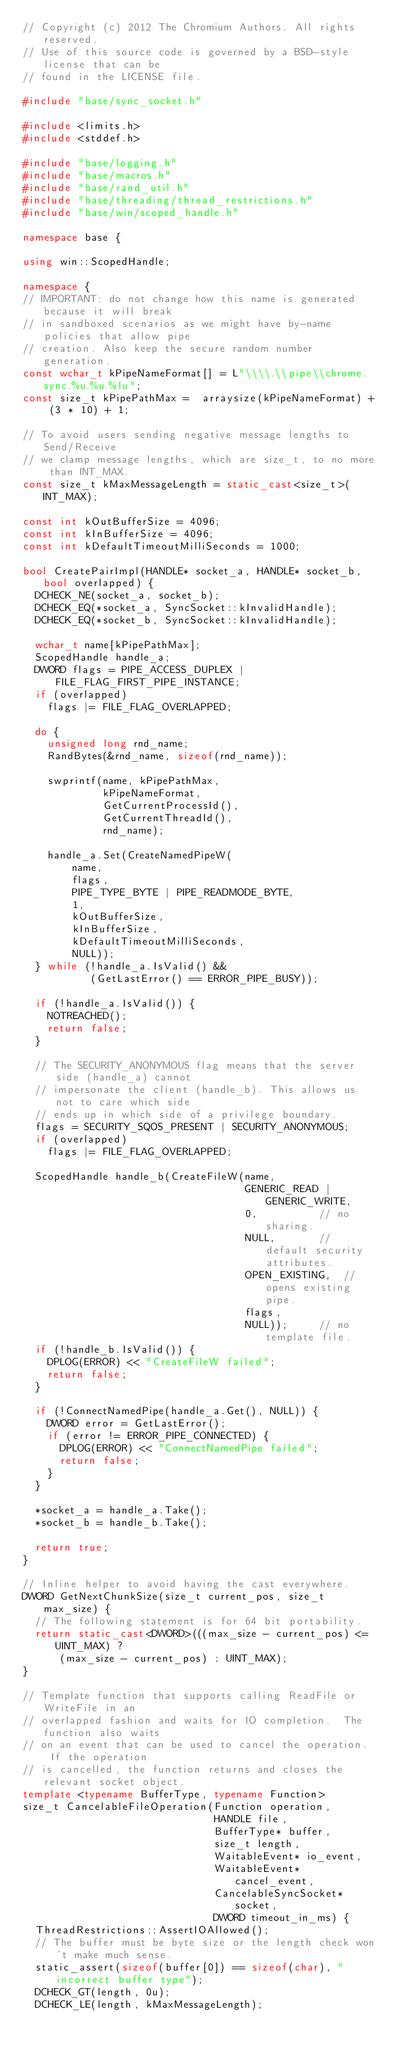<code> <loc_0><loc_0><loc_500><loc_500><_C++_>// Copyright (c) 2012 The Chromium Authors. All rights reserved.
// Use of this source code is governed by a BSD-style license that can be
// found in the LICENSE file.

#include "base/sync_socket.h"

#include <limits.h>
#include <stddef.h>

#include "base/logging.h"
#include "base/macros.h"
#include "base/rand_util.h"
#include "base/threading/thread_restrictions.h"
#include "base/win/scoped_handle.h"

namespace base {

using win::ScopedHandle;

namespace {
// IMPORTANT: do not change how this name is generated because it will break
// in sandboxed scenarios as we might have by-name policies that allow pipe
// creation. Also keep the secure random number generation.
const wchar_t kPipeNameFormat[] = L"\\\\.\\pipe\\chrome.sync.%u.%u.%lu";
const size_t kPipePathMax =  arraysize(kPipeNameFormat) + (3 * 10) + 1;

// To avoid users sending negative message lengths to Send/Receive
// we clamp message lengths, which are size_t, to no more than INT_MAX.
const size_t kMaxMessageLength = static_cast<size_t>(INT_MAX);

const int kOutBufferSize = 4096;
const int kInBufferSize = 4096;
const int kDefaultTimeoutMilliSeconds = 1000;

bool CreatePairImpl(HANDLE* socket_a, HANDLE* socket_b, bool overlapped) {
  DCHECK_NE(socket_a, socket_b);
  DCHECK_EQ(*socket_a, SyncSocket::kInvalidHandle);
  DCHECK_EQ(*socket_b, SyncSocket::kInvalidHandle);

  wchar_t name[kPipePathMax];
  ScopedHandle handle_a;
  DWORD flags = PIPE_ACCESS_DUPLEX | FILE_FLAG_FIRST_PIPE_INSTANCE;
  if (overlapped)
    flags |= FILE_FLAG_OVERLAPPED;

  do {
    unsigned long rnd_name;
    RandBytes(&rnd_name, sizeof(rnd_name));

    swprintf(name, kPipePathMax,
             kPipeNameFormat,
             GetCurrentProcessId(),
             GetCurrentThreadId(),
             rnd_name);

    handle_a.Set(CreateNamedPipeW(
        name,
        flags,
        PIPE_TYPE_BYTE | PIPE_READMODE_BYTE,
        1,
        kOutBufferSize,
        kInBufferSize,
        kDefaultTimeoutMilliSeconds,
        NULL));
  } while (!handle_a.IsValid() &&
           (GetLastError() == ERROR_PIPE_BUSY));

  if (!handle_a.IsValid()) {
    NOTREACHED();
    return false;
  }

  // The SECURITY_ANONYMOUS flag means that the server side (handle_a) cannot
  // impersonate the client (handle_b). This allows us not to care which side
  // ends up in which side of a privilege boundary.
  flags = SECURITY_SQOS_PRESENT | SECURITY_ANONYMOUS;
  if (overlapped)
    flags |= FILE_FLAG_OVERLAPPED;

  ScopedHandle handle_b(CreateFileW(name,
                                    GENERIC_READ | GENERIC_WRITE,
                                    0,          // no sharing.
                                    NULL,       // default security attributes.
                                    OPEN_EXISTING,  // opens existing pipe.
                                    flags,
                                    NULL));     // no template file.
  if (!handle_b.IsValid()) {
    DPLOG(ERROR) << "CreateFileW failed";
    return false;
  }

  if (!ConnectNamedPipe(handle_a.Get(), NULL)) {
    DWORD error = GetLastError();
    if (error != ERROR_PIPE_CONNECTED) {
      DPLOG(ERROR) << "ConnectNamedPipe failed";
      return false;
    }
  }

  *socket_a = handle_a.Take();
  *socket_b = handle_b.Take();

  return true;
}

// Inline helper to avoid having the cast everywhere.
DWORD GetNextChunkSize(size_t current_pos, size_t max_size) {
  // The following statement is for 64 bit portability.
  return static_cast<DWORD>(((max_size - current_pos) <= UINT_MAX) ?
      (max_size - current_pos) : UINT_MAX);
}

// Template function that supports calling ReadFile or WriteFile in an
// overlapped fashion and waits for IO completion.  The function also waits
// on an event that can be used to cancel the operation.  If the operation
// is cancelled, the function returns and closes the relevant socket object.
template <typename BufferType, typename Function>
size_t CancelableFileOperation(Function operation,
                               HANDLE file,
                               BufferType* buffer,
                               size_t length,
                               WaitableEvent* io_event,
                               WaitableEvent* cancel_event,
                               CancelableSyncSocket* socket,
                               DWORD timeout_in_ms) {
  ThreadRestrictions::AssertIOAllowed();
  // The buffer must be byte size or the length check won't make much sense.
  static_assert(sizeof(buffer[0]) == sizeof(char), "incorrect buffer type");
  DCHECK_GT(length, 0u);
  DCHECK_LE(length, kMaxMessageLength);</code> 